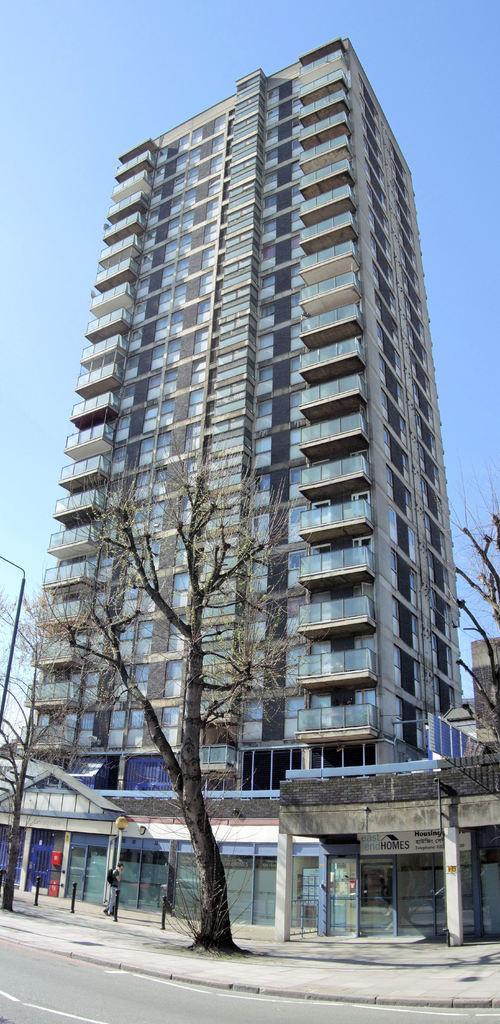Could you give a brief overview of what you see in this image? In this image in the center there is a building, and in the foreground there are some trees, glass doors, some boards and poles. At the bottom there is road, and at the top there is sky. 